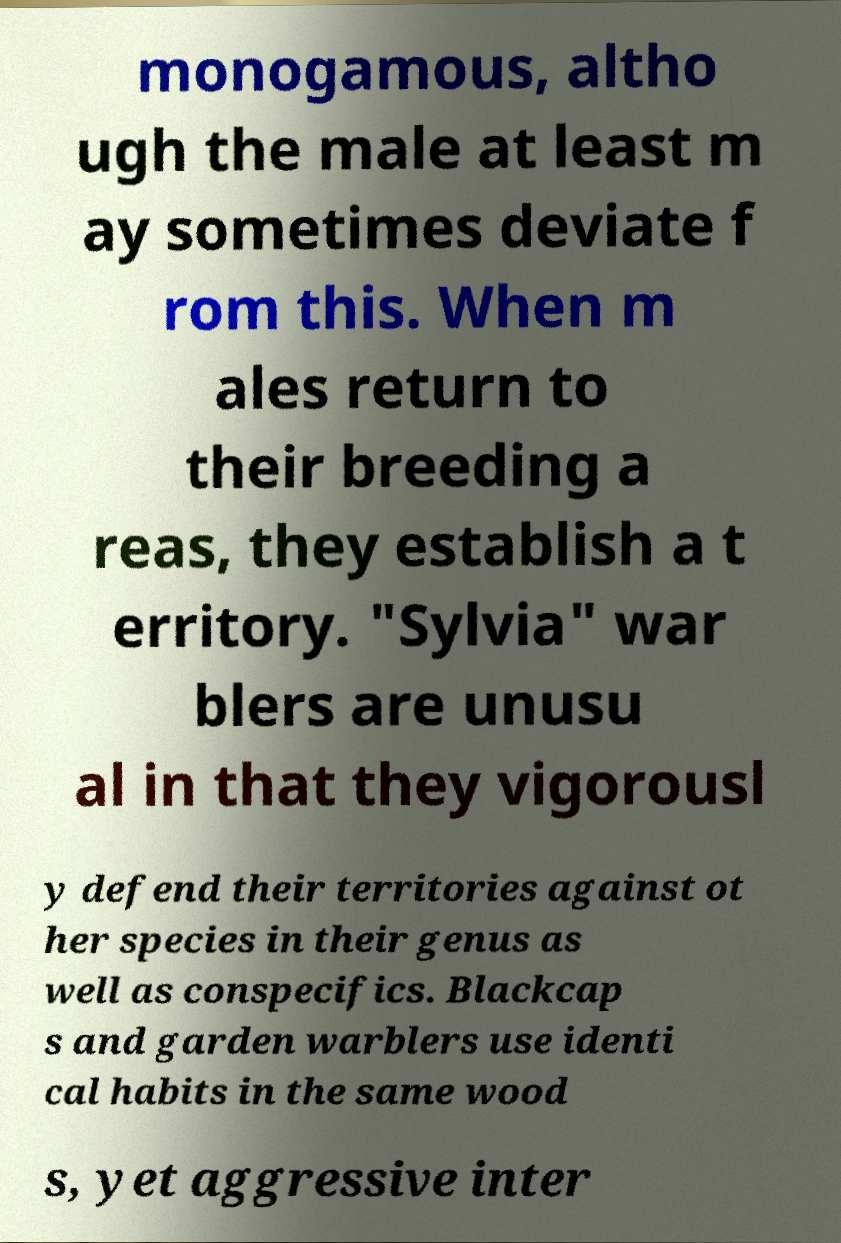Please read and relay the text visible in this image. What does it say? monogamous, altho ugh the male at least m ay sometimes deviate f rom this. When m ales return to their breeding a reas, they establish a t erritory. "Sylvia" war blers are unusu al in that they vigorousl y defend their territories against ot her species in their genus as well as conspecifics. Blackcap s and garden warblers use identi cal habits in the same wood s, yet aggressive inter 